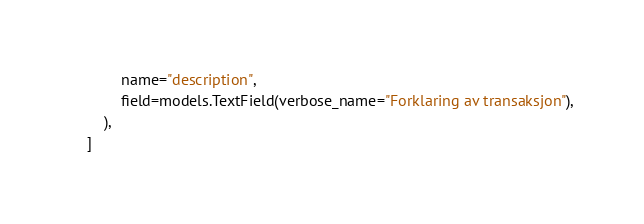Convert code to text. <code><loc_0><loc_0><loc_500><loc_500><_Python_>            name="description",
            field=models.TextField(verbose_name="Forklaring av transaksjon"),
        ),
    ]
</code> 